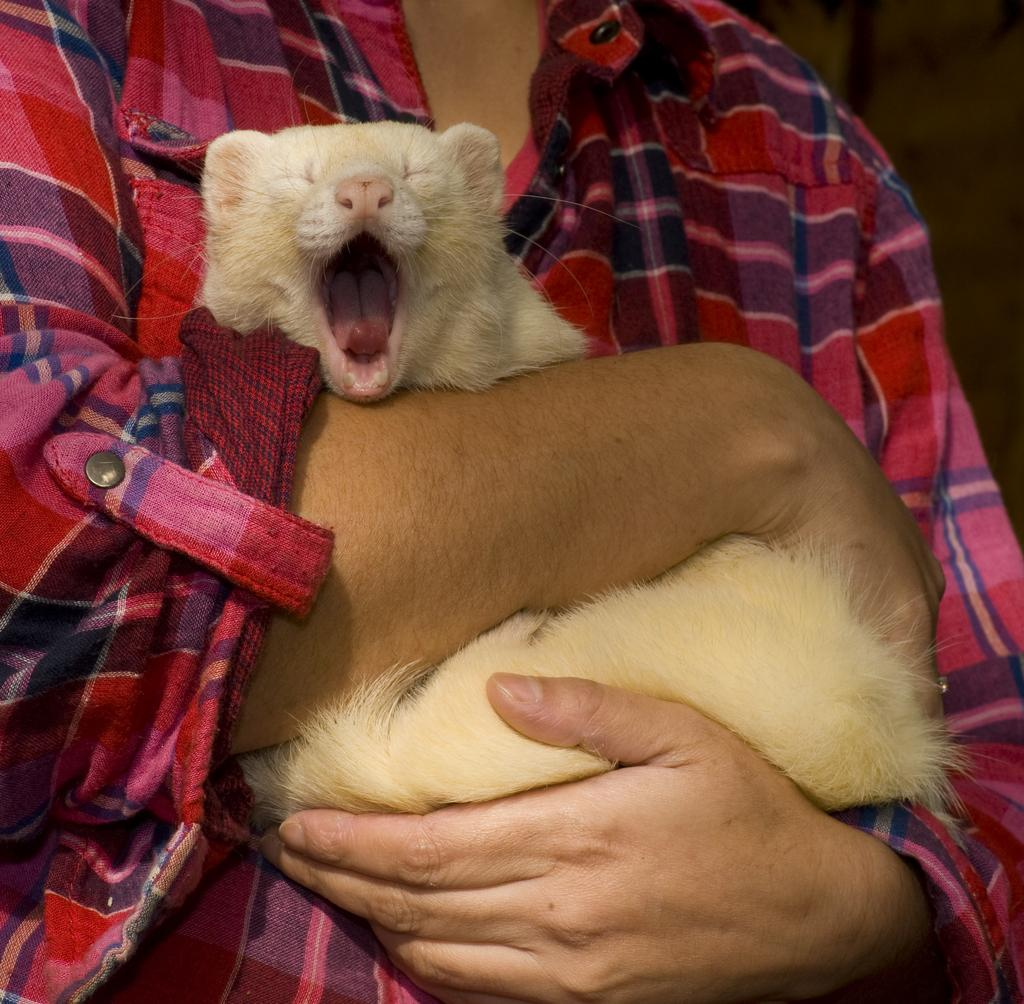What is the main subject of the image? There is a person in the image. What is the person doing in the image? The person is holding an animal with their hands. Can you describe the background of the image? The background of the image is blurry. What nation is protesting in the image? There is no protest or nation present in the image; it features a person holding an animal with their hands against a blurry background. 